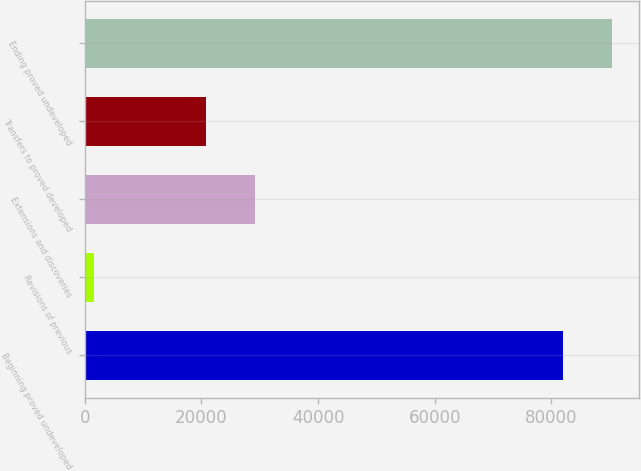<chart> <loc_0><loc_0><loc_500><loc_500><bar_chart><fcel>Beginning proved undeveloped<fcel>Revisions of previous<fcel>Extensions and discoveries<fcel>Transfers to proved developed<fcel>Ending proved undeveloped<nl><fcel>81993<fcel>1590<fcel>29157.2<fcel>20726<fcel>90424.2<nl></chart> 